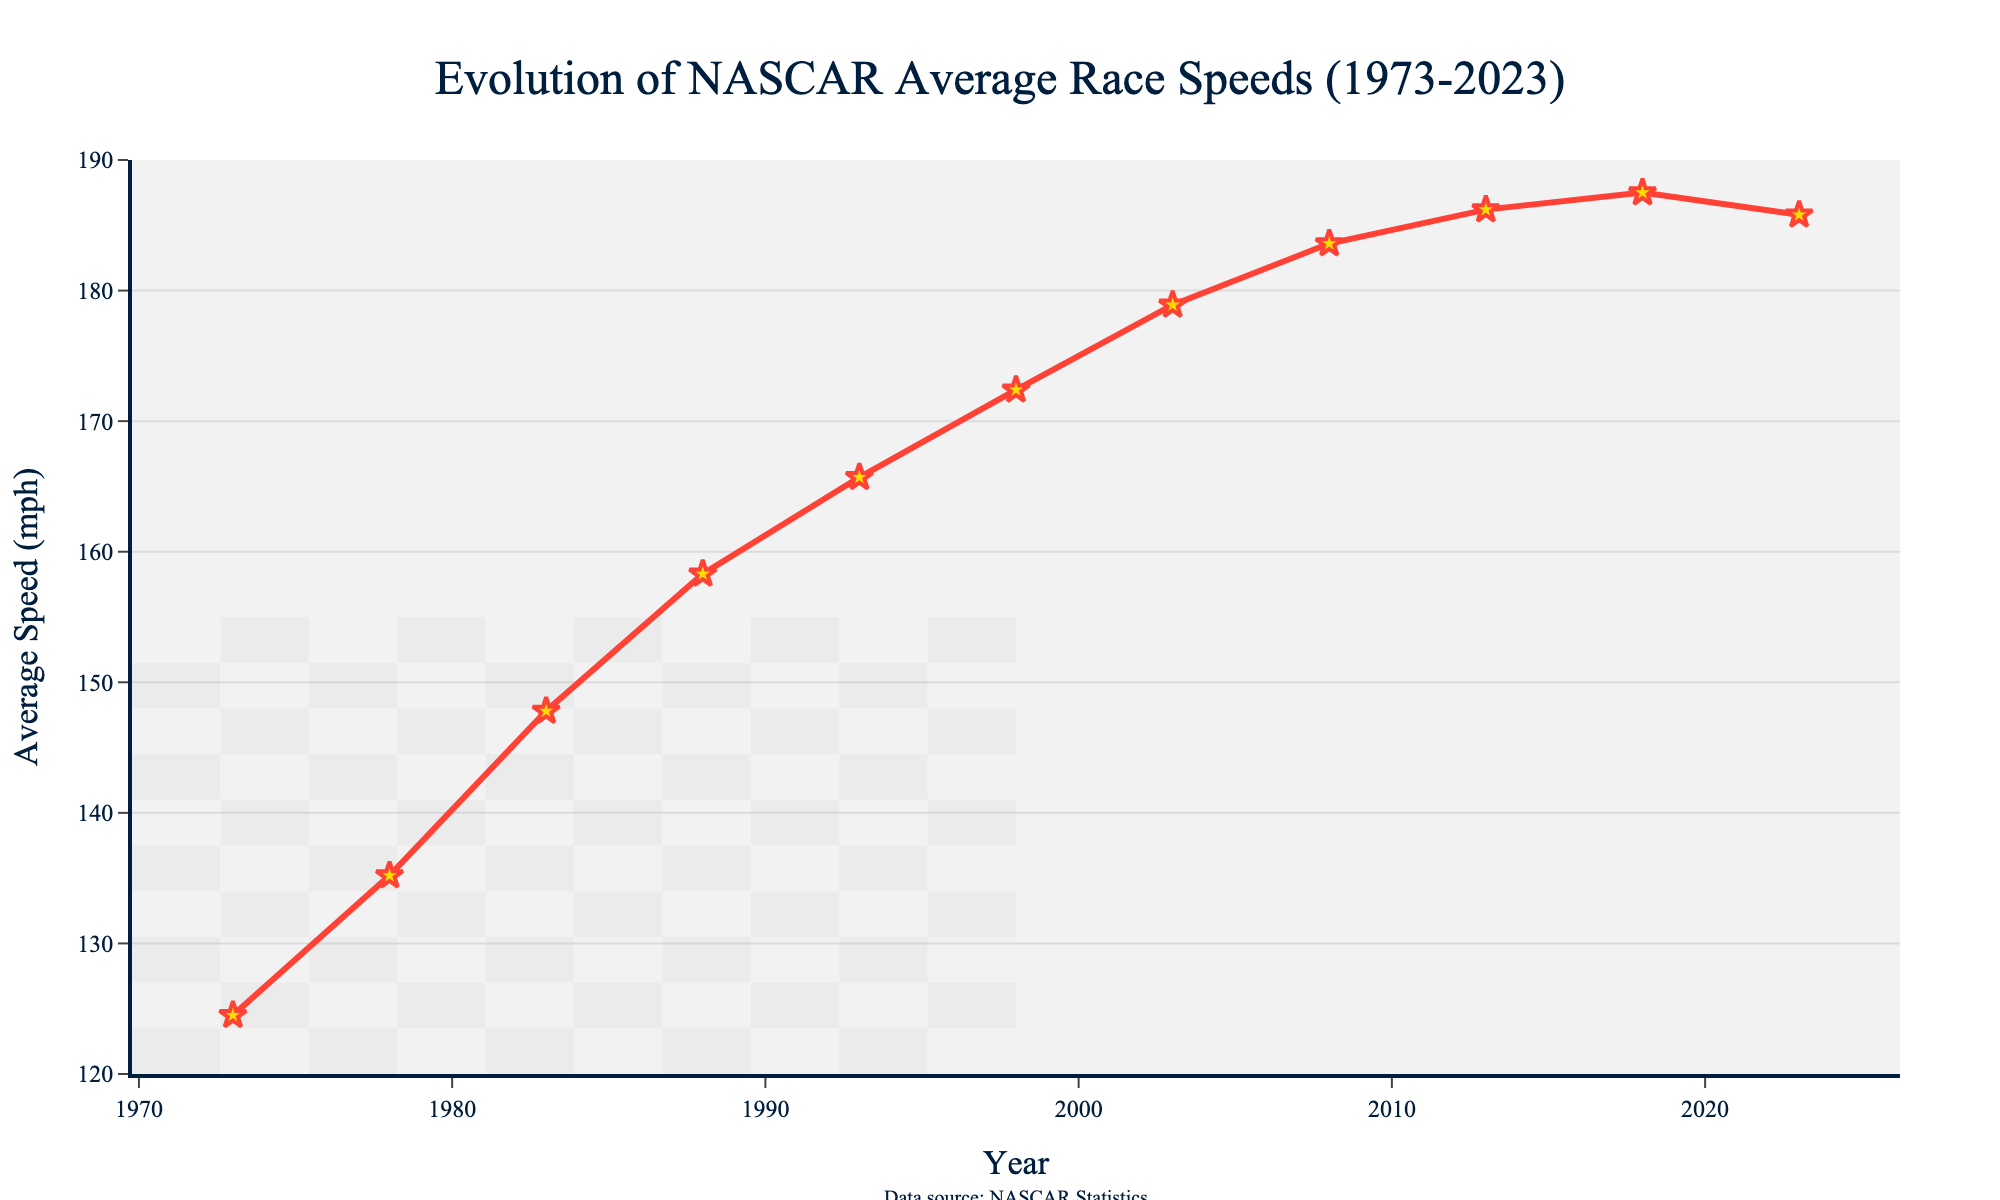What's the highest average speed recorded on the chart? The highest point on the line chart shows the maximum average speed over the years. Locate the peak of the line and the corresponding y-axis value, which is 187.5 mph in 2018.
Answer: 187.5 mph How much did the average speed increase from 1973 to 2023? Find the average speeds for the years 1973 (124.5 mph) and 2023 (185.8 mph). Subtract the 1973 value from the 2023 value: 185.8 - 124.5 = 61.3 mph.
Answer: 61.3 mph Between which years did the average speed increase the most? Identify the segments with the steepest slopes on the line chart. The largest increase appears between 1983 (147.8 mph) and 1988 (158.3 mph), a difference of 10.5 mph.
Answer: 1983-1988 What was the average speed in 1998 compared to 2008? Compare the average speeds for 1998 (172.4 mph) and 2008 (183.6 mph) directly by looking at the y-axis values for both years.
Answer: 1998: 172.4 mph, 2008: 183.6 mph Did the average speed decrease in any five-year span? Examine the chart for any downward slopes within any given five-year periods. From 2018 (187.5 mph) to 2023 (185.8 mph), the average speed decreased by 1.7 mph.
Answer: Yes, 2018-2023 What is the average of the speeds recorded in the first three years (1973, 1978, 1983)? Sum the speeds of the first three years: 124.5 + 135.2 + 147.8 = 407.5. Divide this sum by three: 407.5 / 3 = 135.83 mph.
Answer: 135.83 mph Which decade saw the greatest increase in average speed? Compare the differences in average speed for each decade. The greatest difference occurs between 1980-1990 (1983 to 1988), an increase from 147.8 mph to 158.3 mph, which equals 10.5 mph.
Answer: 1980s Is there any year where the average speed did not increase compared to the previous recorded year? Look for years where the y-value is less than or equal to the previous year's y-value. The speed in 2023 (185.8 mph) is less than in 2018 (187.5 mph).
Answer: Yes, 2023 What is the average speed over the decades of the 2000s and 2010s combined? Sum the average speeds for the years 2003, 2008, 2013, and 2018. Add them up: 178.9 + 183.6 + 186.2 + 187.5 = 736.2. Divide by four: 736.2 / 4 = 184.05 mph.
Answer: 184.05 mph 